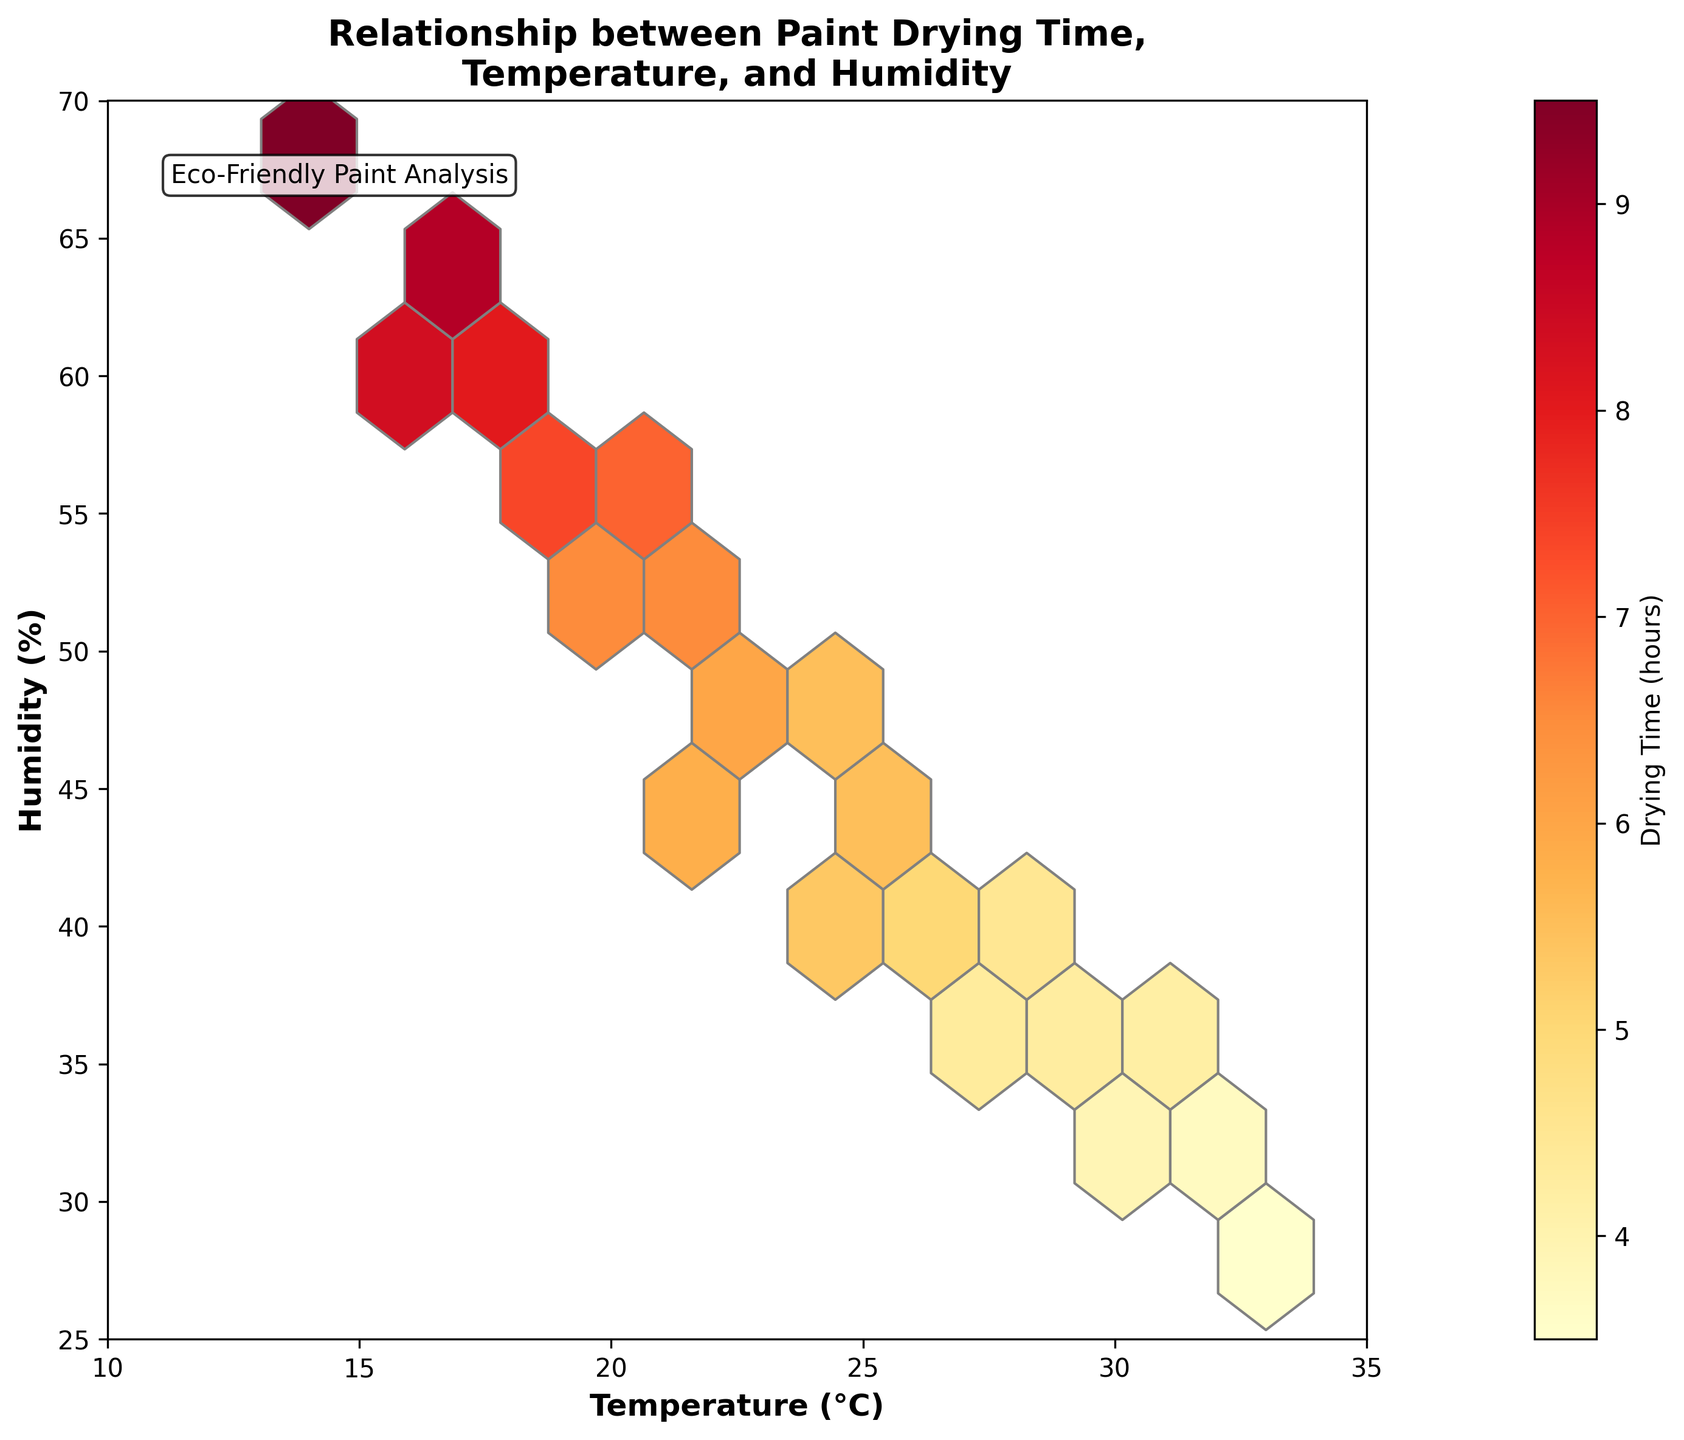What is the title of the figure? The title is typically found at the top of the figure, summarizing its main subject. In this case, it mentions the relationship between different factors affecting paint drying time.
Answer: Relationship between Paint Drying Time, Temperature, and Humidity Which variable is on the x-axis? The x-axis label indicates which variable is presented horizontally.
Answer: Temperature (°C) What color map is used to indicate drying time? The color gradient in a hexbin plot shows the varying intensities of drying time, which in this plot follows a yellow to red scale.
Answer: Yellow to Red (YlOrRd) What is the relationship between temperature and drying time? Observing the hexbin plot, as temperature increases, the color tends to shift towards red, indicating a decrease in drying time. This suggests an inverse relationship.
Answer: Inversely related What general trend do you notice with humidity and drying time? Higher humidity areas appear with darker colors, indicating longer drying times. Therefore, as humidity increases, drying time seems to increase as well.
Answer: Longer drying time with higher humidity How do the drying times vary for temperatures between 20°C and 25°C? Referring to the color gradient between 20°C and 25°C, the drying times are represented by varying hues suggesting a reduction in drying time as temperature rises within this range.
Answer: Decrease in drying time How many temperature-humidity bin counts are shown in the figure? The hexbin plot divides the data into hexagonal cells. The exact number can be counted based on the visible hexagons in the plot.
Answer: 10 x 8 = 80 bins What specific temperature and humidity pair has the longest drying time in the plot? The darkest shaded hexbin cell usually represents the maximum drying time. Finding the corresponding temperature and humidity of this cell will answer the question.
Answer: Around 14°C and 68% Near what temperature and humidity range do we achieve the shortest drying times? Looking at the lighter shades, typically found around lower humidity and higher temperature values, we identify the optimal range for shortest drying times.
Answer: Around 30-33°C and 28-35% How does the drying time distribution appear more densely clustered in the plot? By observing the hexbin color density, it is evident where more frequent drying times occur within certain temperature and humidity ranges.
Answer: Densely clustered around middle humidity and moderate temperatures (18-25°C, 40-55%) 